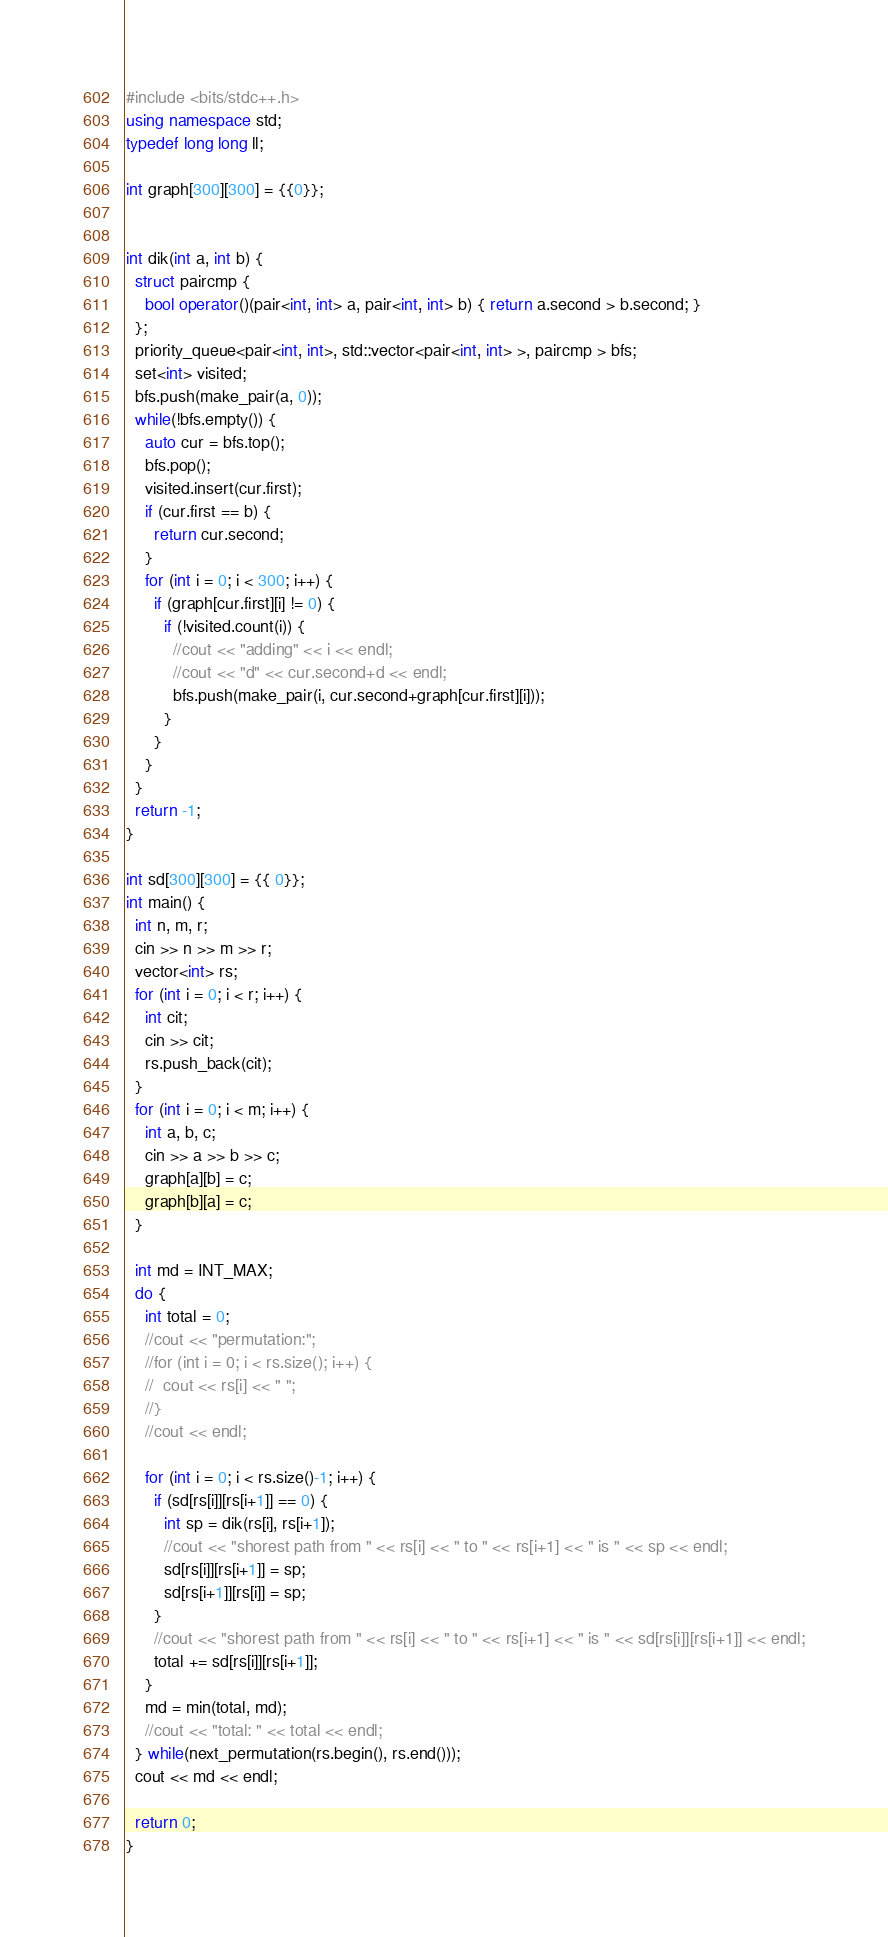Convert code to text. <code><loc_0><loc_0><loc_500><loc_500><_C++_>#include <bits/stdc++.h>
using namespace std;
typedef long long ll;

int graph[300][300] = {{0}};


int dik(int a, int b) {
  struct paircmp {
    bool operator()(pair<int, int> a, pair<int, int> b) { return a.second > b.second; }
  };
  priority_queue<pair<int, int>, std::vector<pair<int, int> >, paircmp > bfs;
  set<int> visited;
  bfs.push(make_pair(a, 0));
  while(!bfs.empty()) {
    auto cur = bfs.top();
    bfs.pop();
    visited.insert(cur.first);
    if (cur.first == b) {
      return cur.second;
    }
    for (int i = 0; i < 300; i++) {
      if (graph[cur.first][i] != 0) {
        if (!visited.count(i)) {
          //cout << "adding" << i << endl;
          //cout << "d" << cur.second+d << endl;
          bfs.push(make_pair(i, cur.second+graph[cur.first][i]));
        }
      }
    }
  }
  return -1;
}

int sd[300][300] = {{ 0}};
int main() {
  int n, m, r;
  cin >> n >> m >> r;
  vector<int> rs;
  for (int i = 0; i < r; i++) {
    int cit;
    cin >> cit;
    rs.push_back(cit);
  }
  for (int i = 0; i < m; i++) {
    int a, b, c;
    cin >> a >> b >> c;
    graph[a][b] = c;
    graph[b][a] = c;
  }

  int md = INT_MAX;
  do {
    int total = 0;
    //cout << "permutation:";
    //for (int i = 0; i < rs.size(); i++) {
    //  cout << rs[i] << " ";
    //}
    //cout << endl;

    for (int i = 0; i < rs.size()-1; i++) {
      if (sd[rs[i]][rs[i+1]] == 0) {
        int sp = dik(rs[i], rs[i+1]);
        //cout << "shorest path from " << rs[i] << " to " << rs[i+1] << " is " << sp << endl;
        sd[rs[i]][rs[i+1]] = sp;
        sd[rs[i+1]][rs[i]] = sp;
      } 
      //cout << "shorest path from " << rs[i] << " to " << rs[i+1] << " is " << sd[rs[i]][rs[i+1]] << endl;
      total += sd[rs[i]][rs[i+1]];
    }
    md = min(total, md);
    //cout << "total: " << total << endl;
  } while(next_permutation(rs.begin(), rs.end()));
  cout << md << endl; 

  return 0;
}
</code> 